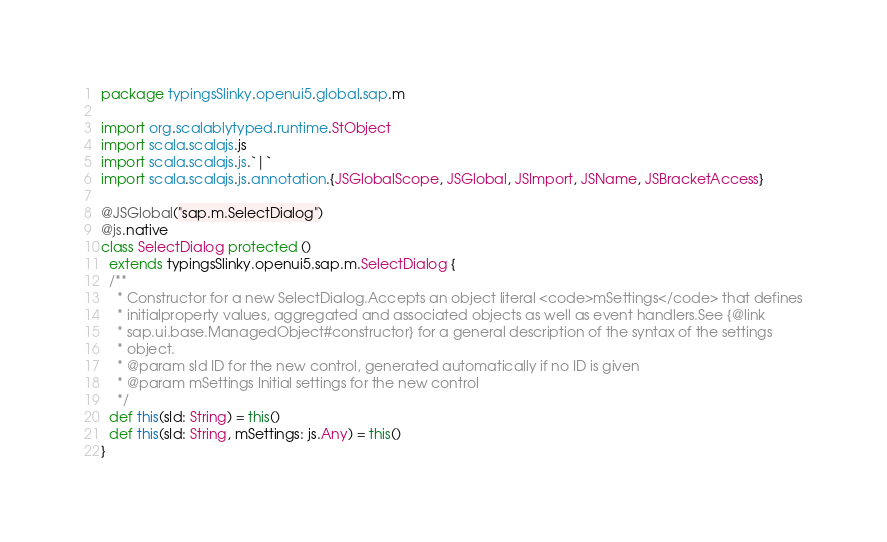Convert code to text. <code><loc_0><loc_0><loc_500><loc_500><_Scala_>package typingsSlinky.openui5.global.sap.m

import org.scalablytyped.runtime.StObject
import scala.scalajs.js
import scala.scalajs.js.`|`
import scala.scalajs.js.annotation.{JSGlobalScope, JSGlobal, JSImport, JSName, JSBracketAccess}

@JSGlobal("sap.m.SelectDialog")
@js.native
class SelectDialog protected ()
  extends typingsSlinky.openui5.sap.m.SelectDialog {
  /**
    * Constructor for a new SelectDialog.Accepts an object literal <code>mSettings</code> that defines
    * initialproperty values, aggregated and associated objects as well as event handlers.See {@link
    * sap.ui.base.ManagedObject#constructor} for a general description of the syntax of the settings
    * object.
    * @param sId ID for the new control, generated automatically if no ID is given
    * @param mSettings Initial settings for the new control
    */
  def this(sId: String) = this()
  def this(sId: String, mSettings: js.Any) = this()
}
</code> 